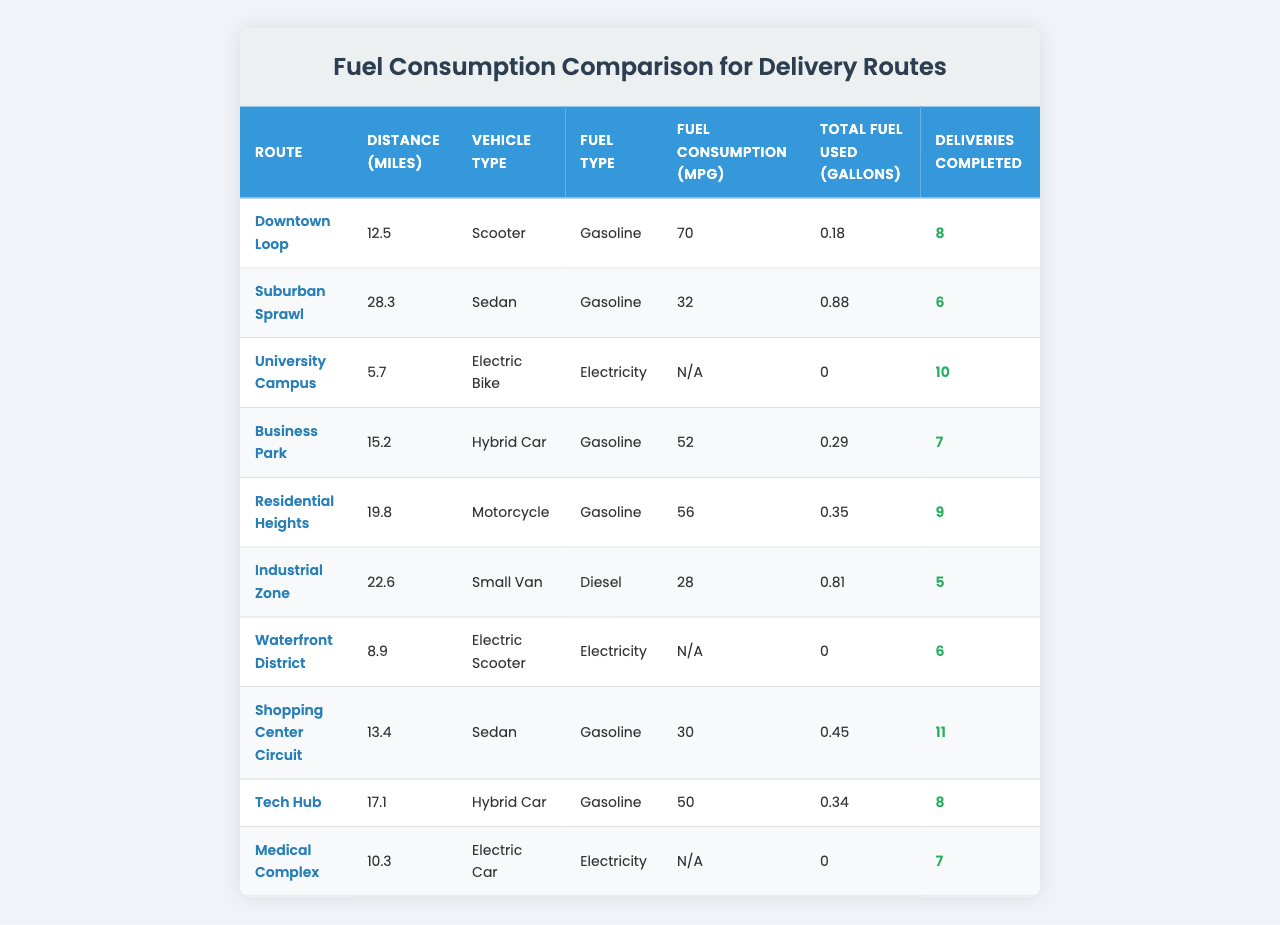What is the total distance of the "Suburban Sprawl" route? The "Suburban Sprawl" route is listed with a distance of 28.3 miles in the table.
Answer: 28.3 miles Which vehicle type has the best fuel consumption? Comparing the fuel consumption in miles per gallon: Scooter (70 mpg), Sedan (32 mpg), Electric Bike (N/A), Hybrid Car (52 mpg), Motorcycle (56 mpg), Small Van (28 mpg), Electric Scooter (N/A), and Electric Car (N/A). The Scooter has the highest value.
Answer: Scooter How much fuel was used in the "Business Park" route? The table states that for the "Business Park" route, total fuel used is 0.29 gallons.
Answer: 0.29 gallons What is the average fuel consumption (mpg) for hybrid vehicles listed in the table? The Hybrid Car has 52 mpg and the other Hybrid Car has 50 mpg. The average is (52 + 50) / 2 = 51 mpg.
Answer: 51 mpg Did the "Electric Bike" require any fuel in gallons? According to the table, the "Electric Bike" has total fuel used listed as 0 gallons.
Answer: Yes, 0 gallons How many deliveries were completed in total across all routes? Summing the completed deliveries: 8 + 6 + 10 + 7 + 9 + 5 + 6 + 11 + 8 + 7 = 77.
Answer: 77 deliveries Which route had the highest number of completed deliveries? By examining the completed deliveries: the "Shopping Center Circuit" has the highest count at 11 deliveries.
Answer: Shopping Center Circuit What is the difference in total fuel used between the "Downtown Loop" and the "Industrial Zone"? The "Downtown Loop" used 0.18 gallons and the "Industrial Zone" used 0.81 gallons. The difference is 0.81 - 0.18 = 0.63 gallons.
Answer: 0.63 gallons Is it true that all electric vehicles have a fuel consumption value available in the table? The table shows that the Electric Bike and Electric Car have no value for fuel consumption, indicating this statement is false.
Answer: No What is the route with the second longest distance? The distances list: Downtown Loop (12.5), Suburban Sprawl (28.3), University Campus (5.7), Business Park (15.2), Residential Heights (19.8), Industrial Zone (22.6), Waterfront District (8.9), Shopping Center Circuit (13.4), Tech Hub (17.1), Medical Complex (10.3). The second longest is "Residential Heights" at 19.8 miles.
Answer: Residential Heights 